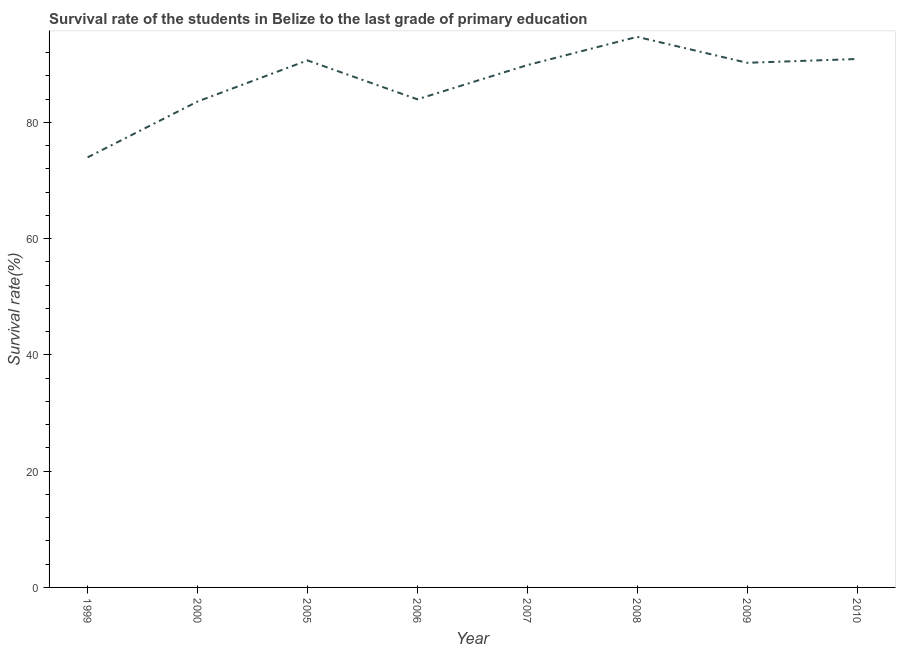What is the survival rate in primary education in 2005?
Make the answer very short. 90.68. Across all years, what is the maximum survival rate in primary education?
Ensure brevity in your answer.  94.73. Across all years, what is the minimum survival rate in primary education?
Make the answer very short. 74. In which year was the survival rate in primary education maximum?
Provide a short and direct response. 2008. In which year was the survival rate in primary education minimum?
Ensure brevity in your answer.  1999. What is the sum of the survival rate in primary education?
Your answer should be compact. 698.03. What is the difference between the survival rate in primary education in 1999 and 2009?
Ensure brevity in your answer.  -16.27. What is the average survival rate in primary education per year?
Keep it short and to the point. 87.25. What is the median survival rate in primary education?
Your answer should be compact. 90.07. In how many years, is the survival rate in primary education greater than 72 %?
Your answer should be compact. 8. What is the ratio of the survival rate in primary education in 1999 to that in 2000?
Your response must be concise. 0.89. What is the difference between the highest and the second highest survival rate in primary education?
Your answer should be very brief. 3.81. What is the difference between the highest and the lowest survival rate in primary education?
Keep it short and to the point. 20.73. Does the survival rate in primary education monotonically increase over the years?
Keep it short and to the point. No. How many lines are there?
Offer a terse response. 1. What is the difference between two consecutive major ticks on the Y-axis?
Provide a succinct answer. 20. Are the values on the major ticks of Y-axis written in scientific E-notation?
Ensure brevity in your answer.  No. Does the graph contain any zero values?
Keep it short and to the point. No. What is the title of the graph?
Give a very brief answer. Survival rate of the students in Belize to the last grade of primary education. What is the label or title of the X-axis?
Make the answer very short. Year. What is the label or title of the Y-axis?
Your answer should be very brief. Survival rate(%). What is the Survival rate(%) in 1999?
Ensure brevity in your answer.  74. What is the Survival rate(%) of 2000?
Make the answer very short. 83.6. What is the Survival rate(%) in 2005?
Offer a very short reply. 90.68. What is the Survival rate(%) of 2006?
Your response must be concise. 83.98. What is the Survival rate(%) of 2007?
Give a very brief answer. 89.87. What is the Survival rate(%) of 2008?
Offer a very short reply. 94.73. What is the Survival rate(%) of 2009?
Make the answer very short. 90.27. What is the Survival rate(%) of 2010?
Provide a short and direct response. 90.92. What is the difference between the Survival rate(%) in 1999 and 2000?
Ensure brevity in your answer.  -9.6. What is the difference between the Survival rate(%) in 1999 and 2005?
Your response must be concise. -16.68. What is the difference between the Survival rate(%) in 1999 and 2006?
Your answer should be compact. -9.99. What is the difference between the Survival rate(%) in 1999 and 2007?
Make the answer very short. -15.87. What is the difference between the Survival rate(%) in 1999 and 2008?
Your response must be concise. -20.73. What is the difference between the Survival rate(%) in 1999 and 2009?
Make the answer very short. -16.27. What is the difference between the Survival rate(%) in 1999 and 2010?
Your answer should be compact. -16.92. What is the difference between the Survival rate(%) in 2000 and 2005?
Offer a very short reply. -7.08. What is the difference between the Survival rate(%) in 2000 and 2006?
Offer a very short reply. -0.38. What is the difference between the Survival rate(%) in 2000 and 2007?
Give a very brief answer. -6.27. What is the difference between the Survival rate(%) in 2000 and 2008?
Your answer should be compact. -11.13. What is the difference between the Survival rate(%) in 2000 and 2009?
Provide a succinct answer. -6.67. What is the difference between the Survival rate(%) in 2000 and 2010?
Make the answer very short. -7.32. What is the difference between the Survival rate(%) in 2005 and 2006?
Keep it short and to the point. 6.69. What is the difference between the Survival rate(%) in 2005 and 2007?
Provide a short and direct response. 0.81. What is the difference between the Survival rate(%) in 2005 and 2008?
Ensure brevity in your answer.  -4.05. What is the difference between the Survival rate(%) in 2005 and 2009?
Provide a short and direct response. 0.41. What is the difference between the Survival rate(%) in 2005 and 2010?
Your answer should be compact. -0.24. What is the difference between the Survival rate(%) in 2006 and 2007?
Make the answer very short. -5.88. What is the difference between the Survival rate(%) in 2006 and 2008?
Offer a terse response. -10.75. What is the difference between the Survival rate(%) in 2006 and 2009?
Your answer should be compact. -6.28. What is the difference between the Survival rate(%) in 2006 and 2010?
Your answer should be very brief. -6.93. What is the difference between the Survival rate(%) in 2007 and 2008?
Offer a terse response. -4.86. What is the difference between the Survival rate(%) in 2007 and 2009?
Your response must be concise. -0.4. What is the difference between the Survival rate(%) in 2007 and 2010?
Keep it short and to the point. -1.05. What is the difference between the Survival rate(%) in 2008 and 2009?
Make the answer very short. 4.46. What is the difference between the Survival rate(%) in 2008 and 2010?
Offer a very short reply. 3.81. What is the difference between the Survival rate(%) in 2009 and 2010?
Keep it short and to the point. -0.65. What is the ratio of the Survival rate(%) in 1999 to that in 2000?
Offer a terse response. 0.89. What is the ratio of the Survival rate(%) in 1999 to that in 2005?
Your answer should be very brief. 0.82. What is the ratio of the Survival rate(%) in 1999 to that in 2006?
Offer a very short reply. 0.88. What is the ratio of the Survival rate(%) in 1999 to that in 2007?
Offer a terse response. 0.82. What is the ratio of the Survival rate(%) in 1999 to that in 2008?
Offer a very short reply. 0.78. What is the ratio of the Survival rate(%) in 1999 to that in 2009?
Offer a very short reply. 0.82. What is the ratio of the Survival rate(%) in 1999 to that in 2010?
Your answer should be very brief. 0.81. What is the ratio of the Survival rate(%) in 2000 to that in 2005?
Provide a short and direct response. 0.92. What is the ratio of the Survival rate(%) in 2000 to that in 2007?
Provide a succinct answer. 0.93. What is the ratio of the Survival rate(%) in 2000 to that in 2008?
Ensure brevity in your answer.  0.88. What is the ratio of the Survival rate(%) in 2000 to that in 2009?
Make the answer very short. 0.93. What is the ratio of the Survival rate(%) in 2005 to that in 2006?
Your response must be concise. 1.08. What is the ratio of the Survival rate(%) in 2005 to that in 2010?
Provide a short and direct response. 1. What is the ratio of the Survival rate(%) in 2006 to that in 2007?
Provide a succinct answer. 0.94. What is the ratio of the Survival rate(%) in 2006 to that in 2008?
Provide a succinct answer. 0.89. What is the ratio of the Survival rate(%) in 2006 to that in 2009?
Give a very brief answer. 0.93. What is the ratio of the Survival rate(%) in 2006 to that in 2010?
Make the answer very short. 0.92. What is the ratio of the Survival rate(%) in 2007 to that in 2008?
Make the answer very short. 0.95. What is the ratio of the Survival rate(%) in 2007 to that in 2009?
Give a very brief answer. 1. What is the ratio of the Survival rate(%) in 2008 to that in 2009?
Provide a short and direct response. 1.05. What is the ratio of the Survival rate(%) in 2008 to that in 2010?
Offer a terse response. 1.04. 